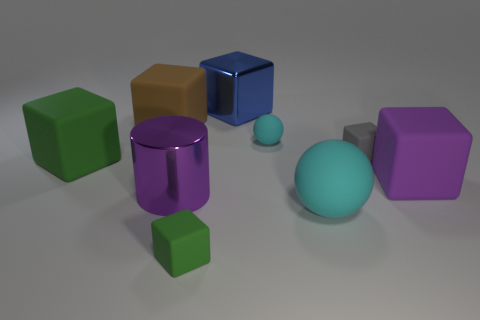Subtract all matte cubes. How many cubes are left? 1 Add 1 large cyan things. How many objects exist? 10 Subtract all green blocks. How many blocks are left? 4 Subtract all cylinders. How many objects are left? 8 Subtract 1 cylinders. How many cylinders are left? 0 Subtract all yellow balls. Subtract all purple blocks. How many balls are left? 2 Add 8 big cyan shiny blocks. How many big cyan shiny blocks exist? 8 Subtract 0 purple spheres. How many objects are left? 9 Subtract all brown balls. How many yellow cubes are left? 0 Subtract all big matte balls. Subtract all small green blocks. How many objects are left? 7 